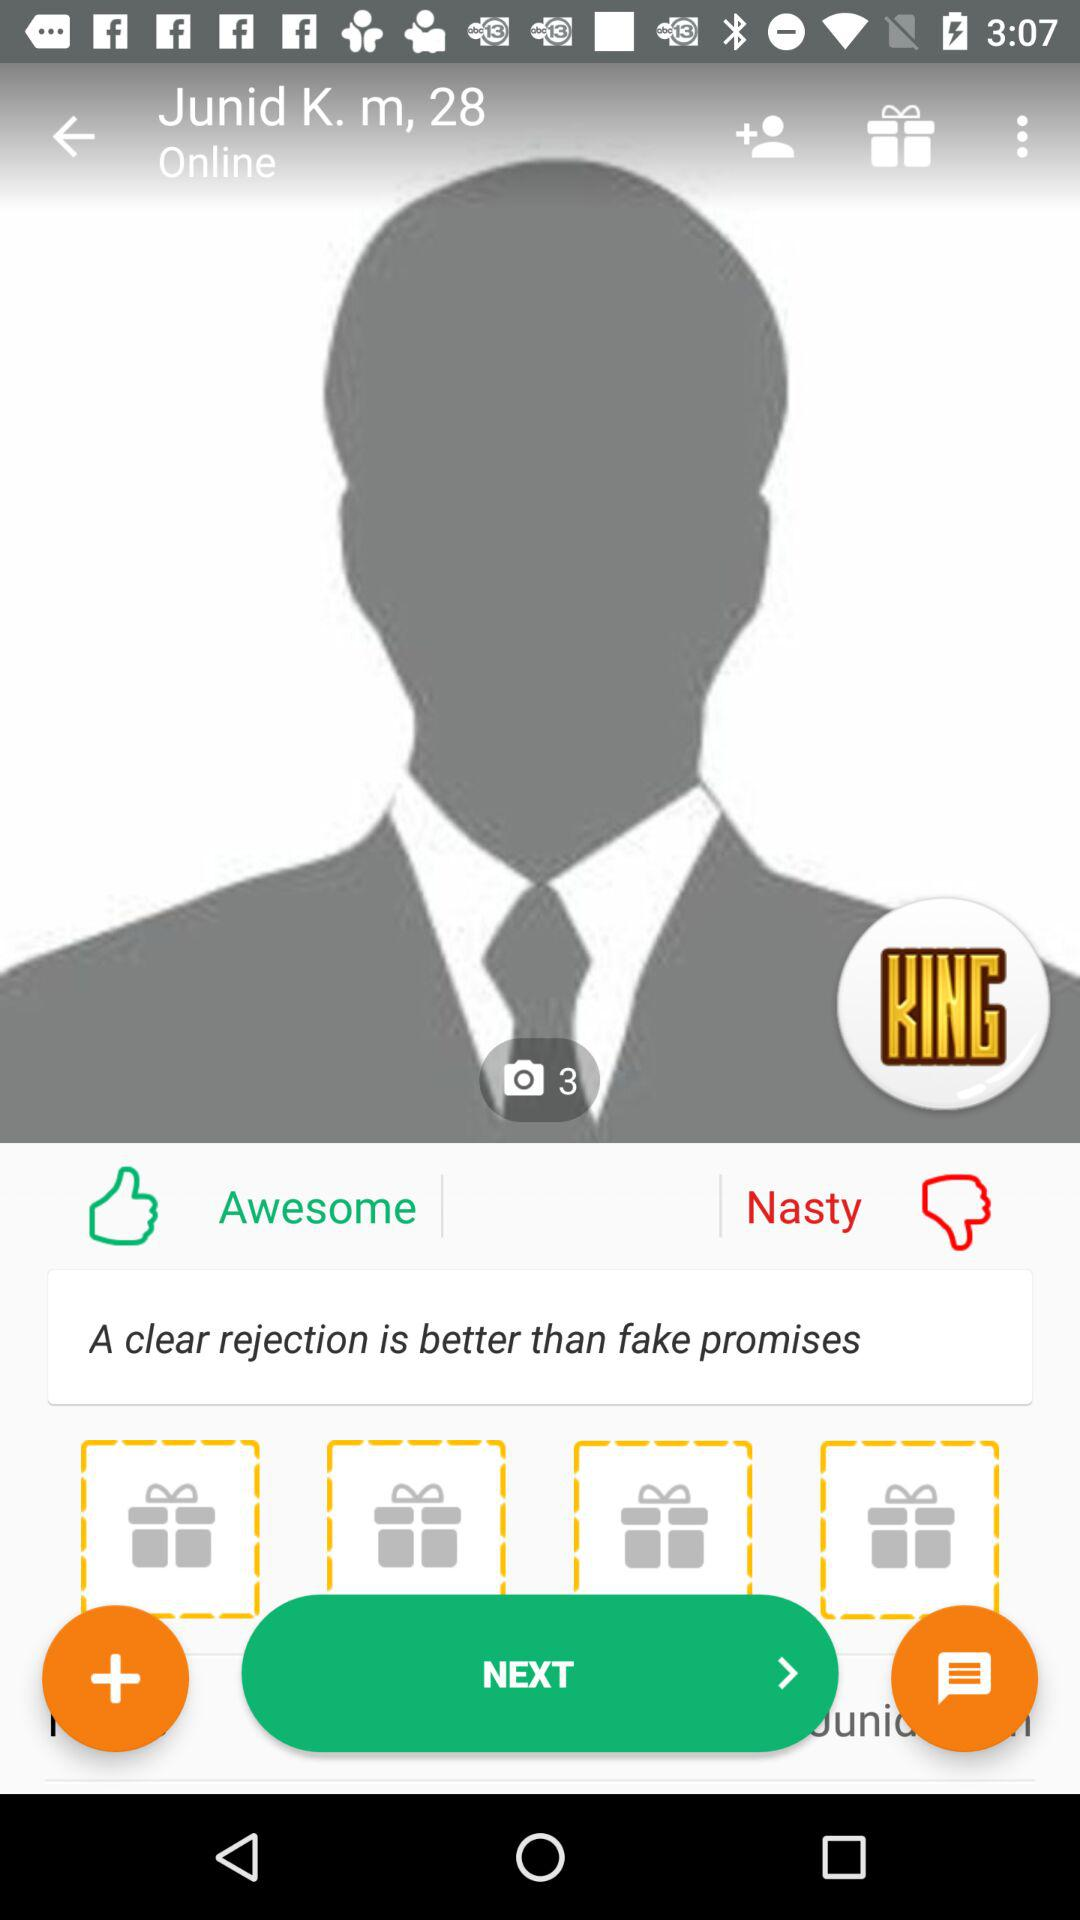How many gifts are on the screen?
Answer the question using a single word or phrase. 4 